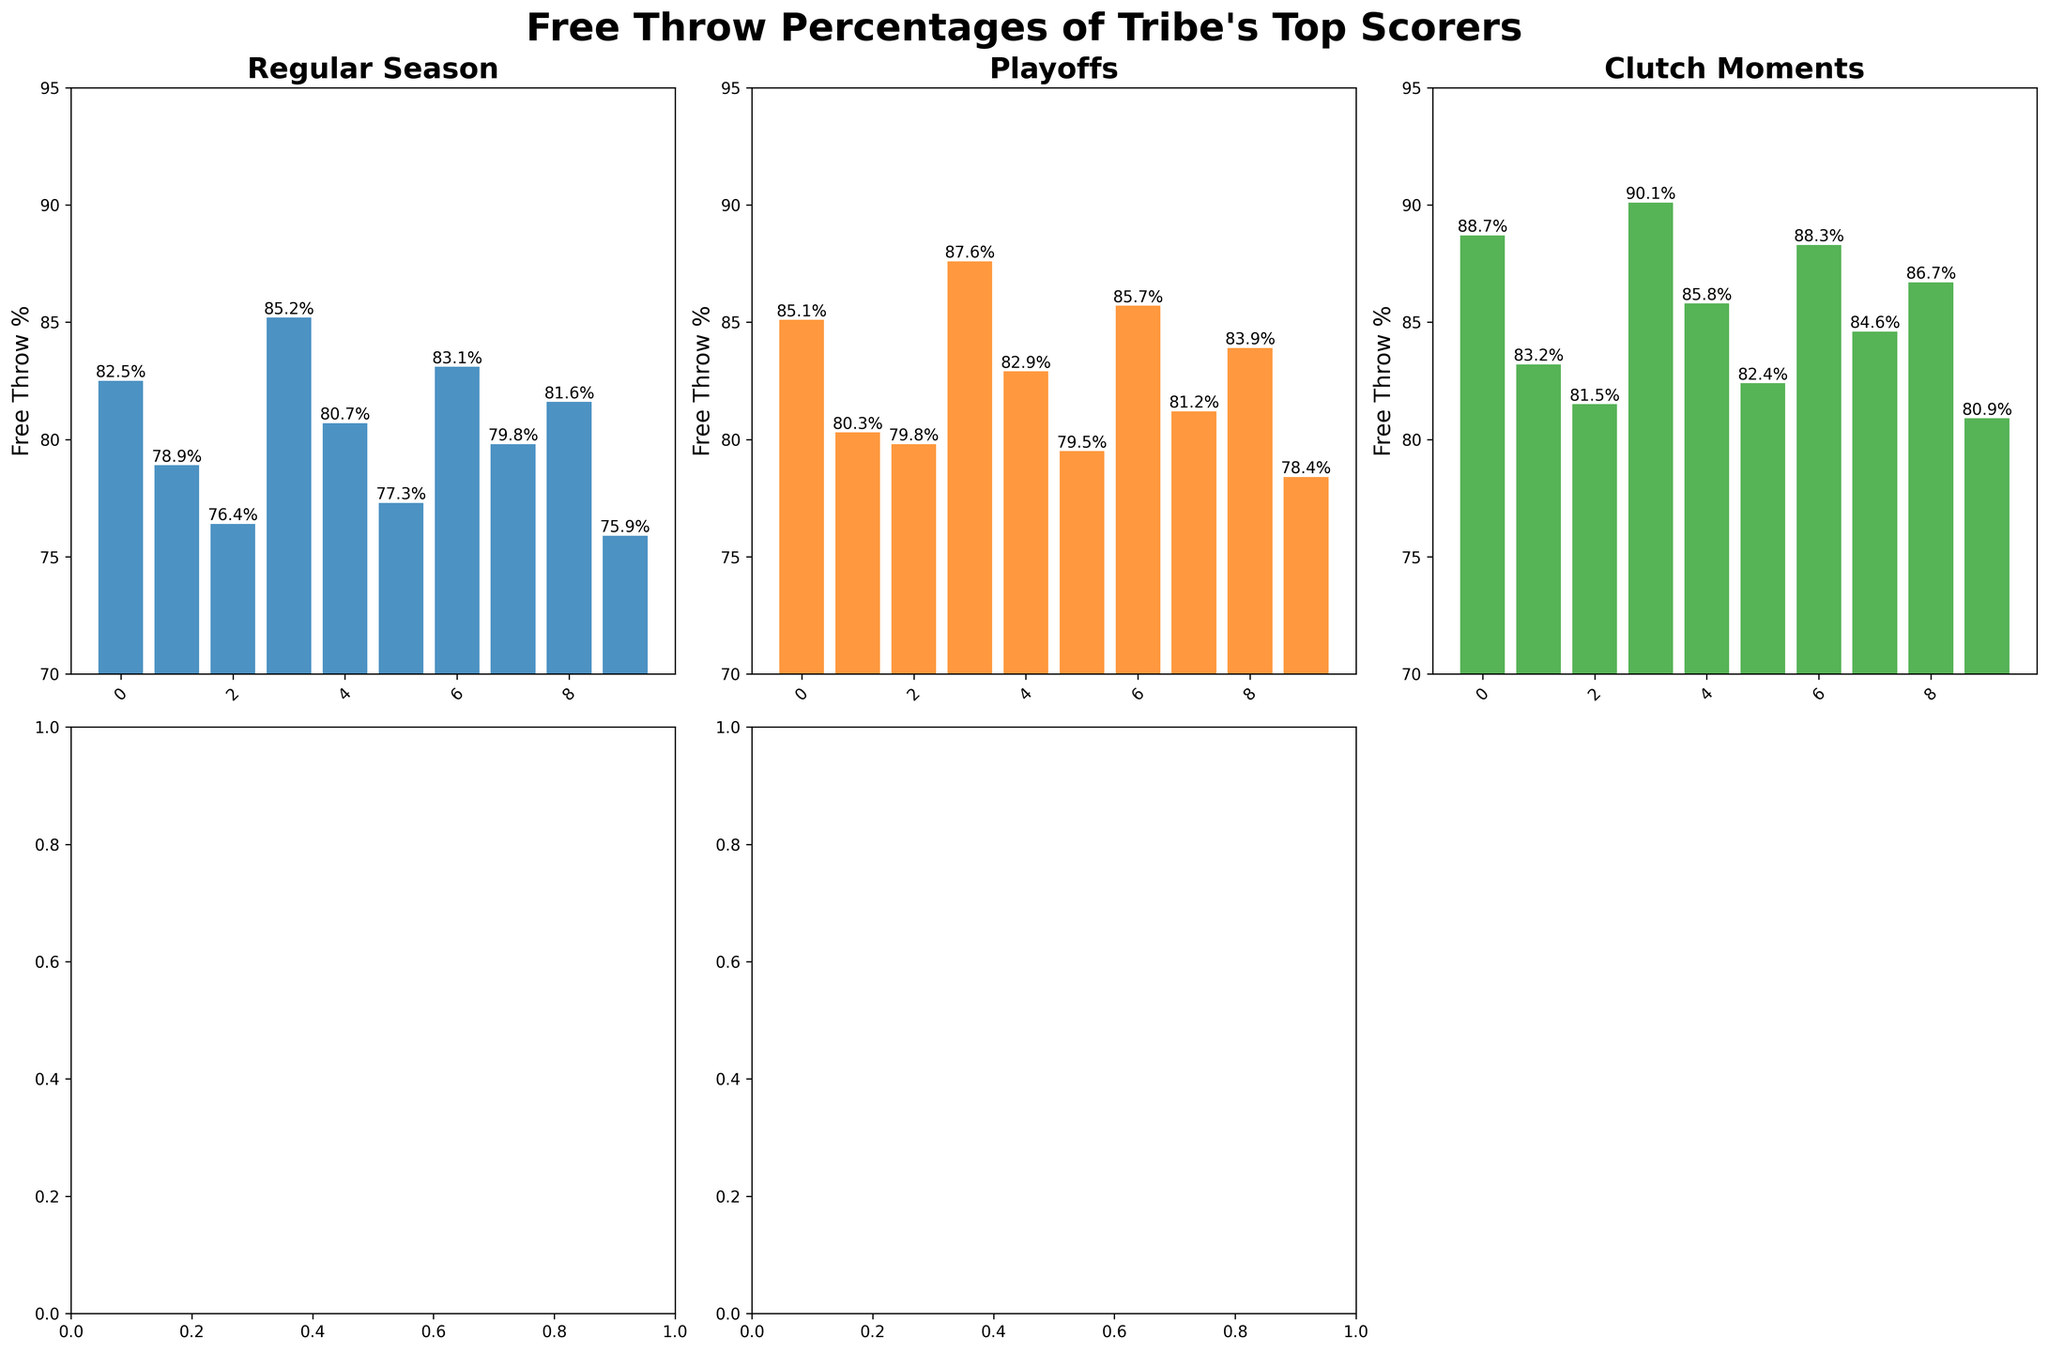Which player has the highest free throw percentage in clutch moments? Look at the "Clutch Moments" subplot, the tallest bar represents Sarah Chen with a free throw percentage of 90.1%.
Answer: Sarah Chen Who has a higher free throw percentage in the regular season, Michael Lee or Rachel Brown? Compare the bars of Michael Lee and Rachel Brown in the "Regular Season" subplot. Michael Lee's bar is shorter (76.4%) than Rachel Brown's (83.1%).
Answer: Rachel Brown What is the difference between Sarah Chen's free throw percentage in the playoffs and David Garcia's free throw percentage in clutch moments? Look at the heights of Sarah Chen's bar in the "Playoffs" subplot (87.6%) and David Garcia's in the "Clutch Moments" subplot (85.8%). The difference is 87.6% - 85.8%.
Answer: 1.8% Which player shows the greatest improvement in free throw percentage from the regular season to clutch moments? Calculate the difference between the "Clutch Moments" and "Regular Season" percentages for each player. Sarah Chen goes from 85.2% to 90.1%, an improvement of 4.9%, which is the highest increase.
Answer: Sarah Chen How many players have a free throw percentage higher than 80% in the regular season? Count the number of bars in the "Regular Season" subplot that are taller than the 80% mark: John Smith, Emma Johnson, Sarah Chen, David Garcia, Rachel Brown, Chris Walker, and Jessica Patel. There are 7 players.
Answer: 7 Which player has the lowest free throw percentage in the playoffs? Look at the "Playoffs" subplot and identify the shortest bar, which represents Marcus Wilson with a percentage of 78.4%.
Answer: Marcus Wilson Compare John Smith's free throw percentage progression from the regular season to clutch moments and Jessica Patel's progression over these game situations. Who shows more consistency? Calculate the percentage differences for both players:
- John Smith: from 82.5% (Regular Season) to 88.7% (Clutch Moments), an increase of 6.2%
- Jessica Patel: from 81.6% (Regular Season) to 86.7% (Clutch Moments), an increase of 5.1%
John Smith has a larger change, so Jessica Patel shows more consistency.
Answer: Jessica Patel What is the average free throw percentage in clutch moments for the top 5 players shown in the chart? Identify the top 5 percentages in the "Clutch Moments" subplot: Sarah Chen (90.1%), John Smith (88.7%), Rachel Brown (88.3%), Jessica Patel (86.7%), and David Garcia (85.8%). Calculate their average: (90.1 + 88.7 + 88.3 + 86.7 + 85.8) / 5 = 87.92%.
Answer: 87.92% What color represents the "Playoffs" game situation in the subplot? Look at the bar colors in the "Playoffs" subplot, which are orange.
Answer: Orange How much higher is Emma Johnson's free throw percentage in the playoffs compared to her regular season percentage? Check Emma Johnson's percentages: 80.3% (Playoffs) and 78.9% (Regular Season). Calculate the difference: 80.3% - 78.9% = 1.4%.
Answer: 1.4% 